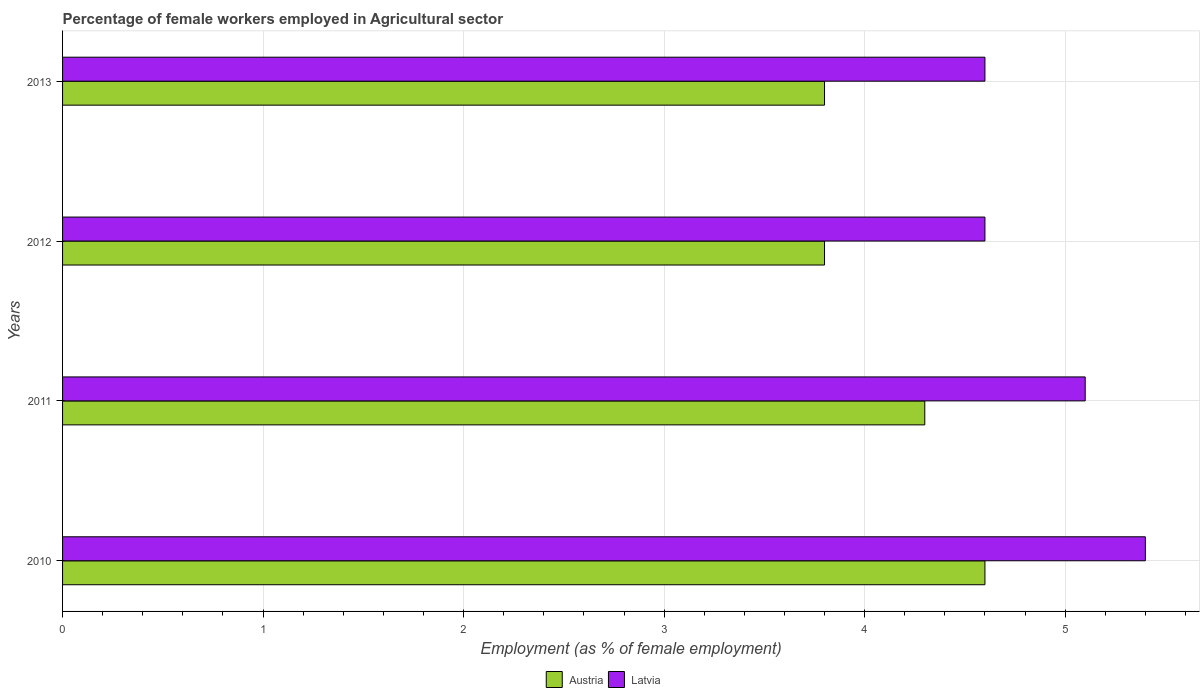How many groups of bars are there?
Give a very brief answer. 4. Are the number of bars per tick equal to the number of legend labels?
Ensure brevity in your answer.  Yes. Are the number of bars on each tick of the Y-axis equal?
Your response must be concise. Yes. How many bars are there on the 2nd tick from the bottom?
Offer a terse response. 2. What is the label of the 3rd group of bars from the top?
Your response must be concise. 2011. What is the percentage of females employed in Agricultural sector in Austria in 2013?
Provide a short and direct response. 3.8. Across all years, what is the maximum percentage of females employed in Agricultural sector in Latvia?
Keep it short and to the point. 5.4. Across all years, what is the minimum percentage of females employed in Agricultural sector in Latvia?
Offer a very short reply. 4.6. In which year was the percentage of females employed in Agricultural sector in Latvia maximum?
Provide a succinct answer. 2010. What is the total percentage of females employed in Agricultural sector in Austria in the graph?
Your answer should be very brief. 16.5. What is the average percentage of females employed in Agricultural sector in Latvia per year?
Make the answer very short. 4.92. In the year 2012, what is the difference between the percentage of females employed in Agricultural sector in Latvia and percentage of females employed in Agricultural sector in Austria?
Provide a short and direct response. 0.8. What is the ratio of the percentage of females employed in Agricultural sector in Latvia in 2010 to that in 2011?
Keep it short and to the point. 1.06. What is the difference between the highest and the second highest percentage of females employed in Agricultural sector in Austria?
Your response must be concise. 0.3. What is the difference between the highest and the lowest percentage of females employed in Agricultural sector in Latvia?
Give a very brief answer. 0.8. What does the 1st bar from the top in 2011 represents?
Your response must be concise. Latvia. What does the 1st bar from the bottom in 2012 represents?
Your answer should be compact. Austria. How many years are there in the graph?
Give a very brief answer. 4. What is the difference between two consecutive major ticks on the X-axis?
Keep it short and to the point. 1. Are the values on the major ticks of X-axis written in scientific E-notation?
Ensure brevity in your answer.  No. Does the graph contain any zero values?
Offer a terse response. No. Does the graph contain grids?
Provide a short and direct response. Yes. How many legend labels are there?
Make the answer very short. 2. What is the title of the graph?
Provide a short and direct response. Percentage of female workers employed in Agricultural sector. What is the label or title of the X-axis?
Give a very brief answer. Employment (as % of female employment). What is the Employment (as % of female employment) of Austria in 2010?
Give a very brief answer. 4.6. What is the Employment (as % of female employment) in Latvia in 2010?
Make the answer very short. 5.4. What is the Employment (as % of female employment) in Austria in 2011?
Your answer should be very brief. 4.3. What is the Employment (as % of female employment) in Latvia in 2011?
Provide a short and direct response. 5.1. What is the Employment (as % of female employment) in Austria in 2012?
Offer a terse response. 3.8. What is the Employment (as % of female employment) in Latvia in 2012?
Provide a succinct answer. 4.6. What is the Employment (as % of female employment) of Austria in 2013?
Your answer should be compact. 3.8. What is the Employment (as % of female employment) in Latvia in 2013?
Keep it short and to the point. 4.6. Across all years, what is the maximum Employment (as % of female employment) in Austria?
Provide a short and direct response. 4.6. Across all years, what is the maximum Employment (as % of female employment) in Latvia?
Make the answer very short. 5.4. Across all years, what is the minimum Employment (as % of female employment) of Austria?
Provide a succinct answer. 3.8. Across all years, what is the minimum Employment (as % of female employment) of Latvia?
Your answer should be very brief. 4.6. What is the total Employment (as % of female employment) in Austria in the graph?
Provide a succinct answer. 16.5. What is the difference between the Employment (as % of female employment) in Austria in 2010 and that in 2011?
Your response must be concise. 0.3. What is the difference between the Employment (as % of female employment) of Latvia in 2010 and that in 2011?
Offer a terse response. 0.3. What is the difference between the Employment (as % of female employment) in Austria in 2010 and that in 2012?
Ensure brevity in your answer.  0.8. What is the difference between the Employment (as % of female employment) of Latvia in 2011 and that in 2012?
Provide a short and direct response. 0.5. What is the difference between the Employment (as % of female employment) of Latvia in 2011 and that in 2013?
Make the answer very short. 0.5. What is the difference between the Employment (as % of female employment) of Austria in 2012 and that in 2013?
Offer a very short reply. 0. What is the difference between the Employment (as % of female employment) of Latvia in 2012 and that in 2013?
Provide a short and direct response. 0. What is the difference between the Employment (as % of female employment) in Austria in 2010 and the Employment (as % of female employment) in Latvia in 2012?
Your response must be concise. 0. What is the difference between the Employment (as % of female employment) of Austria in 2010 and the Employment (as % of female employment) of Latvia in 2013?
Your answer should be compact. 0. What is the difference between the Employment (as % of female employment) of Austria in 2011 and the Employment (as % of female employment) of Latvia in 2013?
Offer a very short reply. -0.3. What is the average Employment (as % of female employment) of Austria per year?
Give a very brief answer. 4.12. What is the average Employment (as % of female employment) of Latvia per year?
Ensure brevity in your answer.  4.92. In the year 2011, what is the difference between the Employment (as % of female employment) in Austria and Employment (as % of female employment) in Latvia?
Your answer should be compact. -0.8. In the year 2012, what is the difference between the Employment (as % of female employment) of Austria and Employment (as % of female employment) of Latvia?
Your response must be concise. -0.8. What is the ratio of the Employment (as % of female employment) of Austria in 2010 to that in 2011?
Your response must be concise. 1.07. What is the ratio of the Employment (as % of female employment) of Latvia in 2010 to that in 2011?
Your answer should be very brief. 1.06. What is the ratio of the Employment (as % of female employment) in Austria in 2010 to that in 2012?
Provide a succinct answer. 1.21. What is the ratio of the Employment (as % of female employment) of Latvia in 2010 to that in 2012?
Offer a terse response. 1.17. What is the ratio of the Employment (as % of female employment) of Austria in 2010 to that in 2013?
Your answer should be very brief. 1.21. What is the ratio of the Employment (as % of female employment) of Latvia in 2010 to that in 2013?
Provide a short and direct response. 1.17. What is the ratio of the Employment (as % of female employment) of Austria in 2011 to that in 2012?
Make the answer very short. 1.13. What is the ratio of the Employment (as % of female employment) of Latvia in 2011 to that in 2012?
Your response must be concise. 1.11. What is the ratio of the Employment (as % of female employment) of Austria in 2011 to that in 2013?
Keep it short and to the point. 1.13. What is the ratio of the Employment (as % of female employment) of Latvia in 2011 to that in 2013?
Offer a very short reply. 1.11. What is the ratio of the Employment (as % of female employment) in Latvia in 2012 to that in 2013?
Offer a terse response. 1. What is the difference between the highest and the second highest Employment (as % of female employment) in Latvia?
Your answer should be very brief. 0.3. What is the difference between the highest and the lowest Employment (as % of female employment) of Austria?
Your answer should be compact. 0.8. 